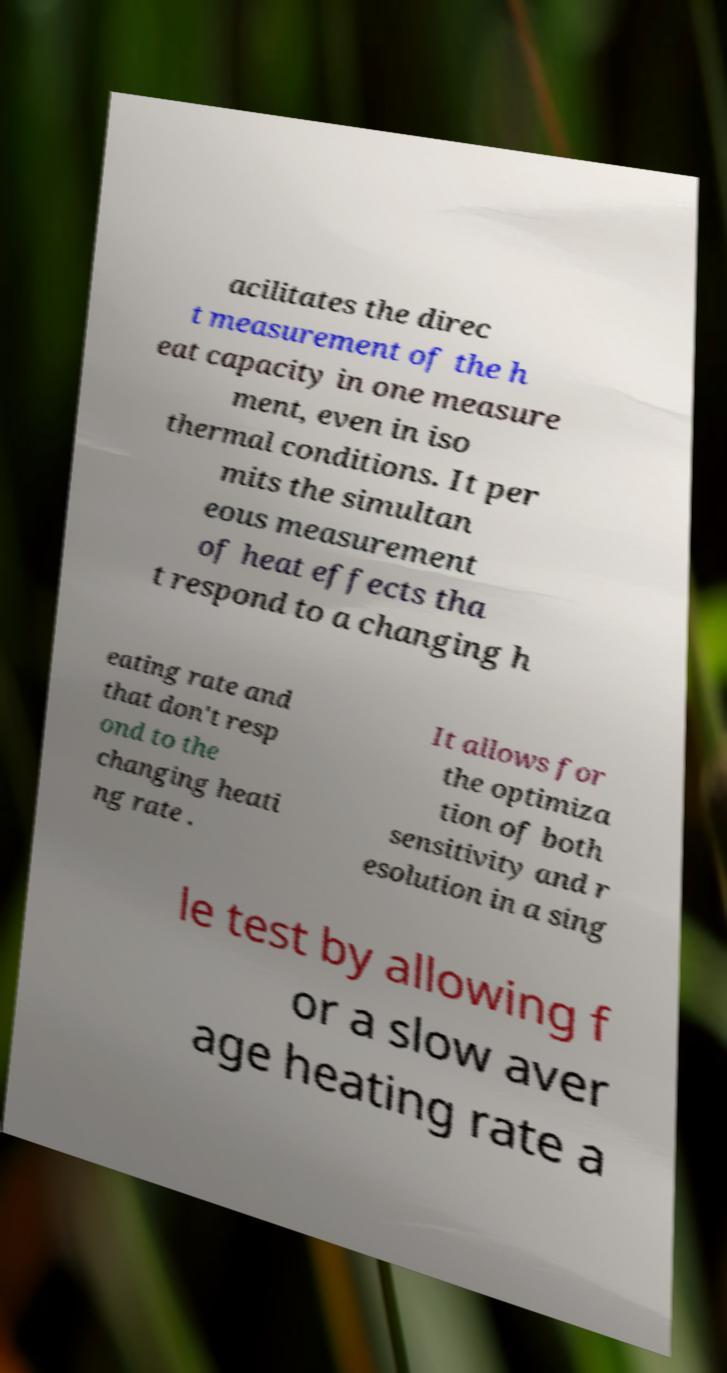Can you accurately transcribe the text from the provided image for me? acilitates the direc t measurement of the h eat capacity in one measure ment, even in iso thermal conditions. It per mits the simultan eous measurement of heat effects tha t respond to a changing h eating rate and that don't resp ond to the changing heati ng rate . It allows for the optimiza tion of both sensitivity and r esolution in a sing le test by allowing f or a slow aver age heating rate a 